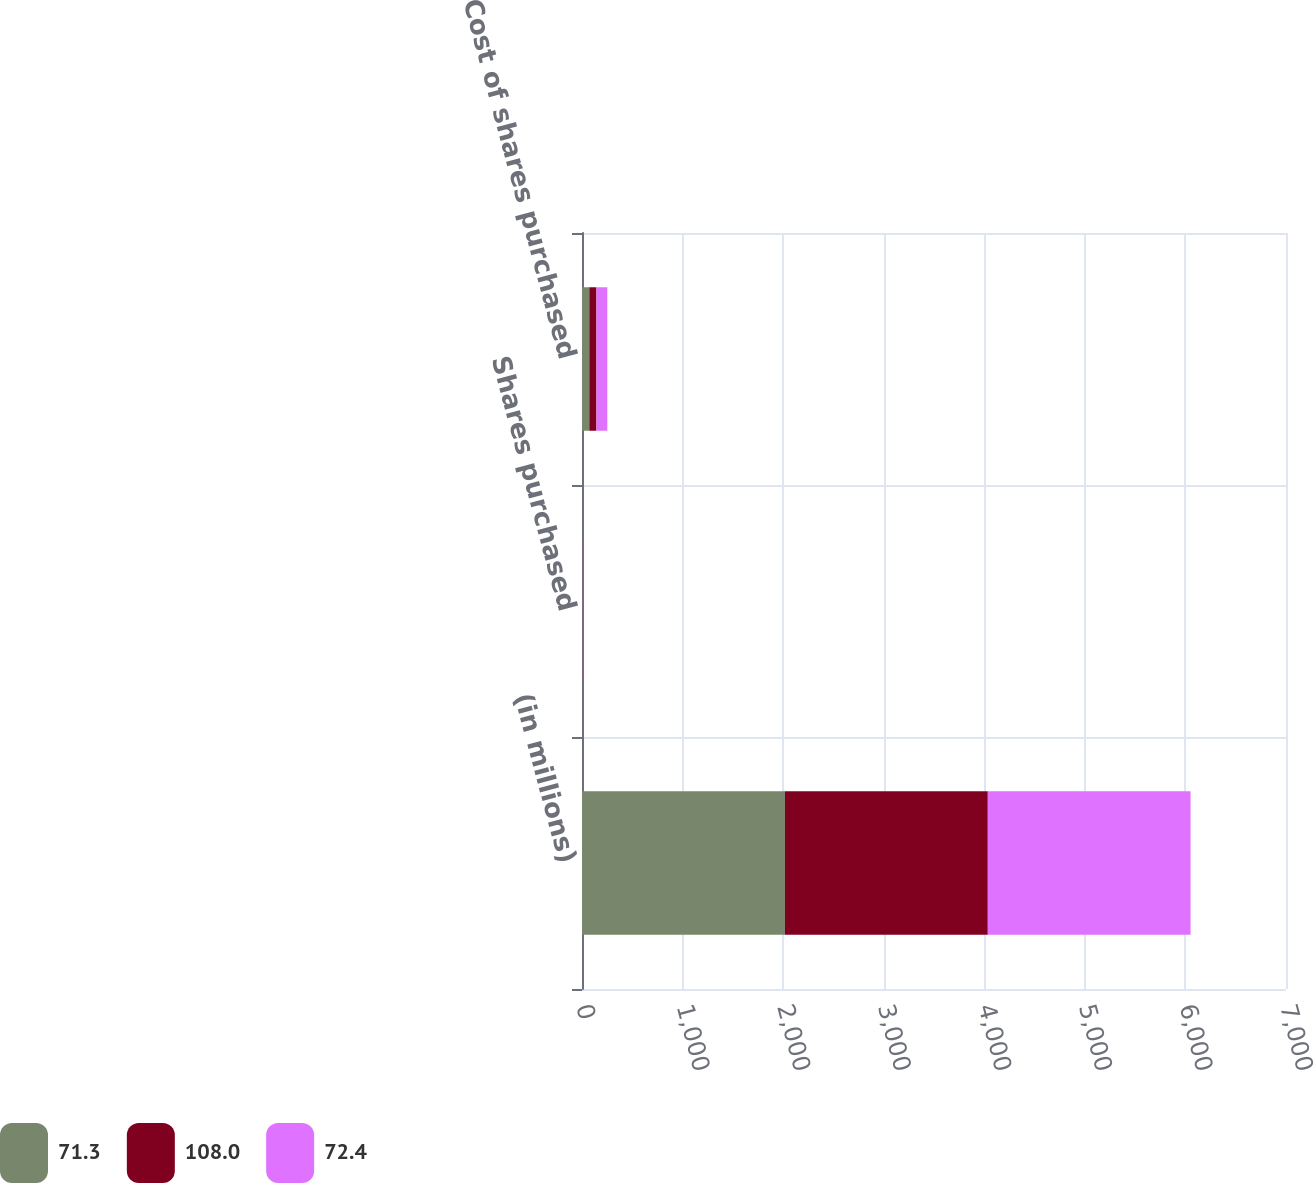Convert chart to OTSL. <chart><loc_0><loc_0><loc_500><loc_500><stacked_bar_chart><ecel><fcel>(in millions)<fcel>Shares purchased<fcel>Cost of shares purchased<nl><fcel>71.3<fcel>2018<fcel>1.1<fcel>72.4<nl><fcel>108<fcel>2017<fcel>1.1<fcel>71.3<nl><fcel>72.4<fcel>2016<fcel>1.8<fcel>108<nl></chart> 